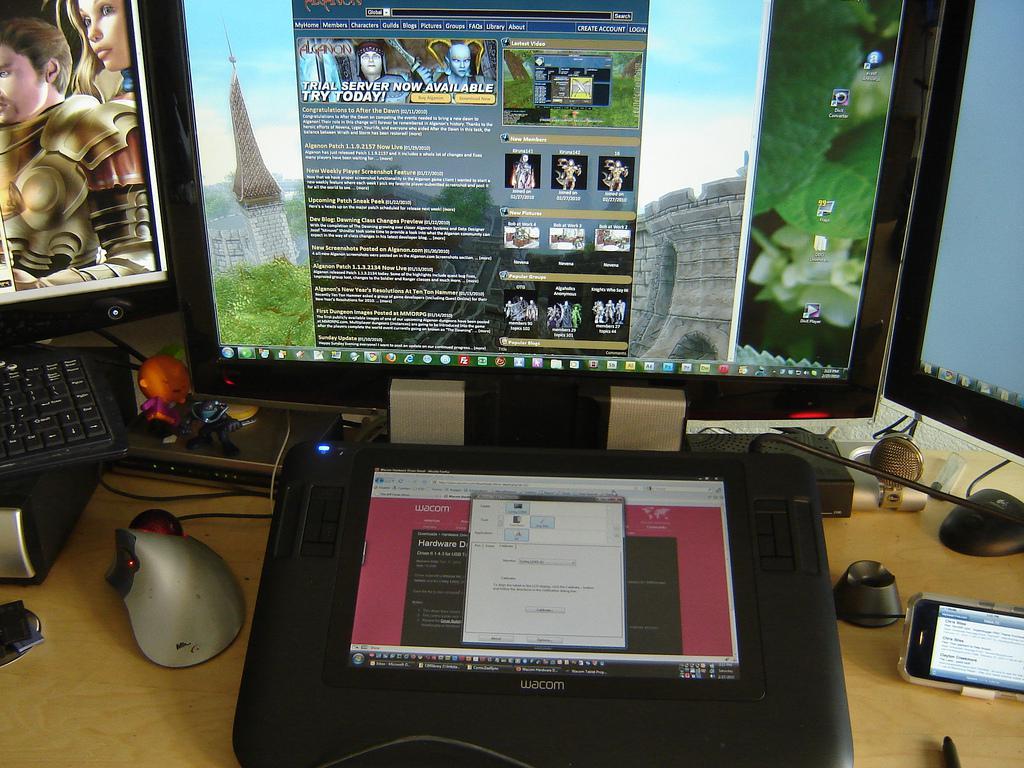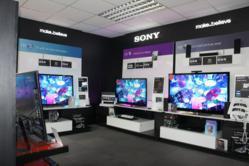The first image is the image on the left, the second image is the image on the right. For the images shown, is this caption "There are no women featured in any of the images." true? Answer yes or no. Yes. The first image is the image on the left, the second image is the image on the right. For the images shown, is this caption "Atleast one image contains a computer monitor." true? Answer yes or no. Yes. 